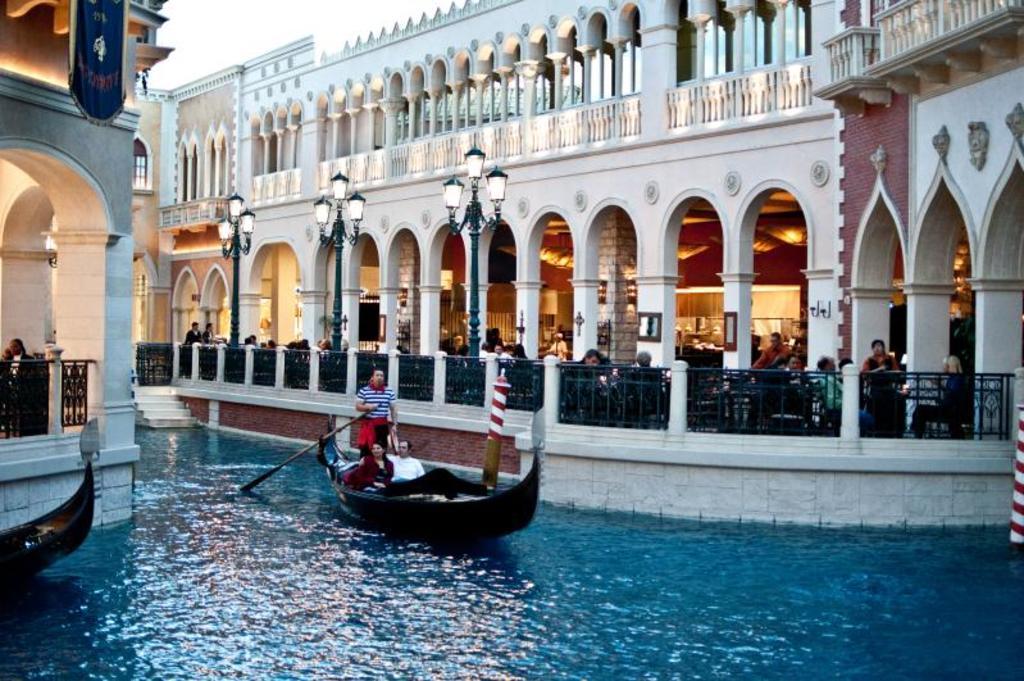In one or two sentences, can you explain what this image depicts? In the middle a person is standing and rowing the boat, 2 persons are sitting on it. This is water, on the right side there is a building, there are people in it. In the middle there are lights. 